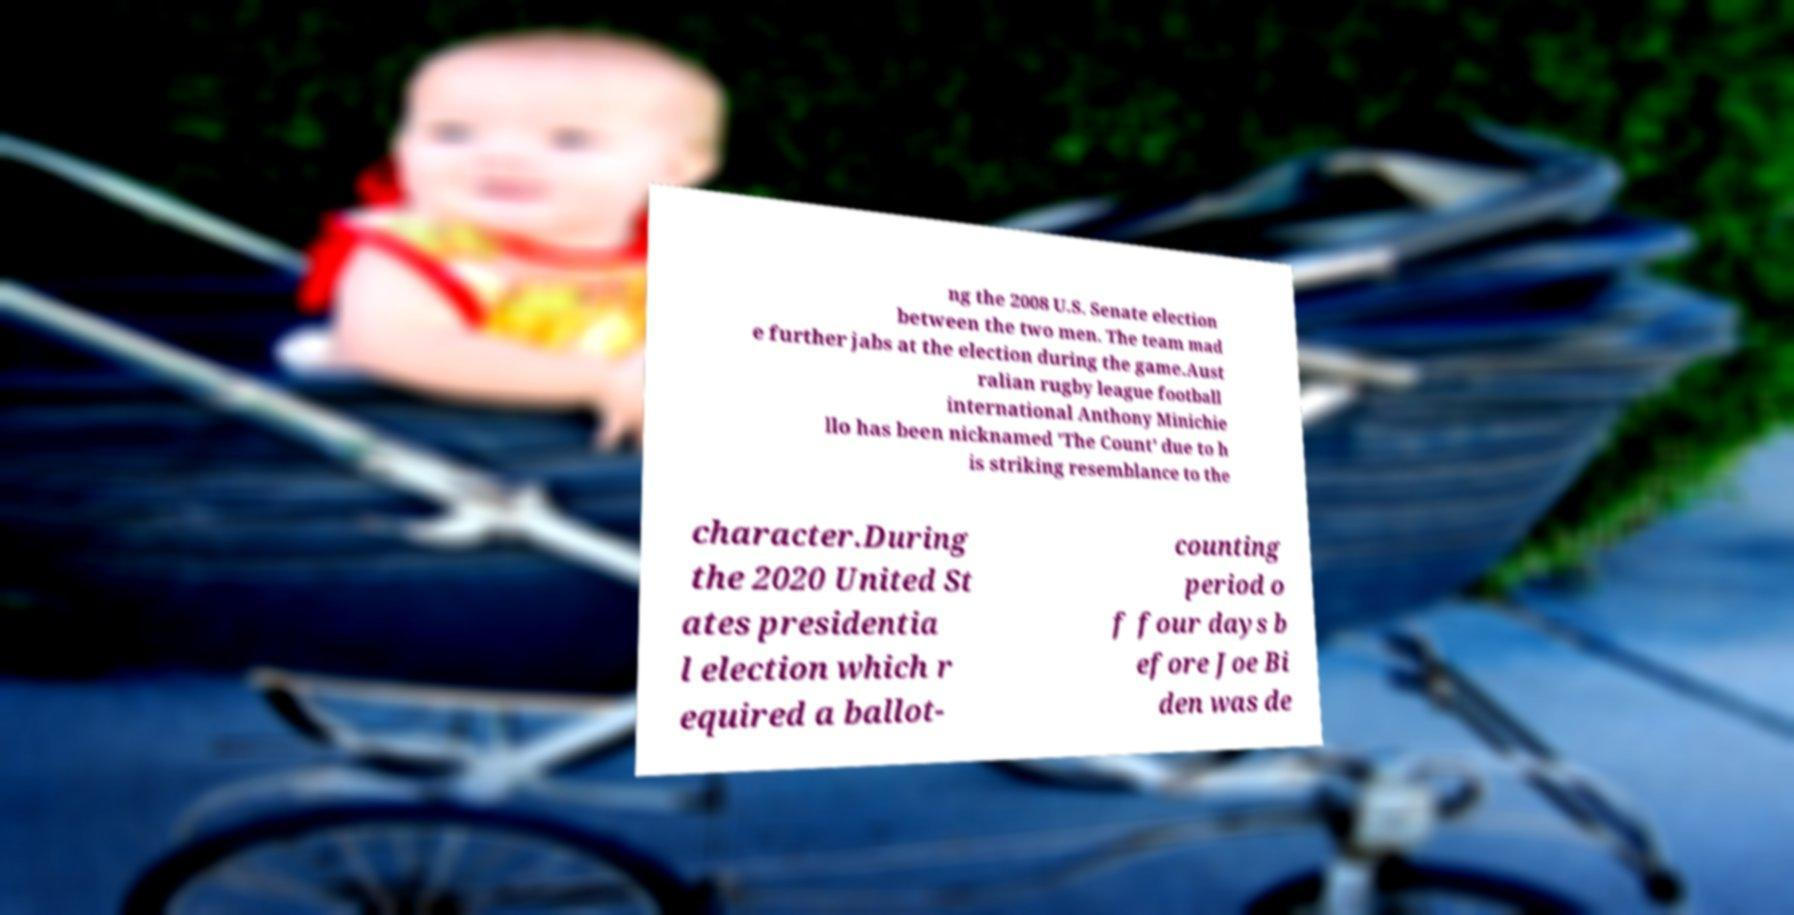Can you accurately transcribe the text from the provided image for me? ng the 2008 U.S. Senate election between the two men. The team mad e further jabs at the election during the game.Aust ralian rugby league football international Anthony Minichie llo has been nicknamed 'The Count' due to h is striking resemblance to the character.During the 2020 United St ates presidentia l election which r equired a ballot- counting period o f four days b efore Joe Bi den was de 